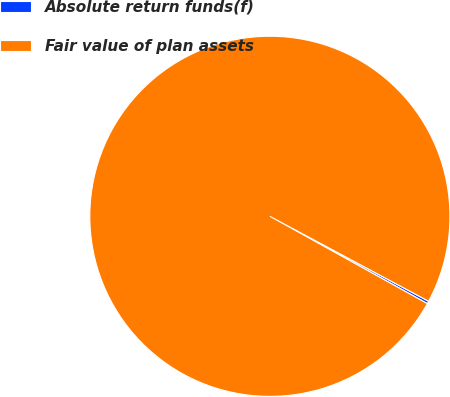Convert chart to OTSL. <chart><loc_0><loc_0><loc_500><loc_500><pie_chart><fcel>Absolute return funds(f)<fcel>Fair value of plan assets<nl><fcel>0.24%<fcel>99.76%<nl></chart> 